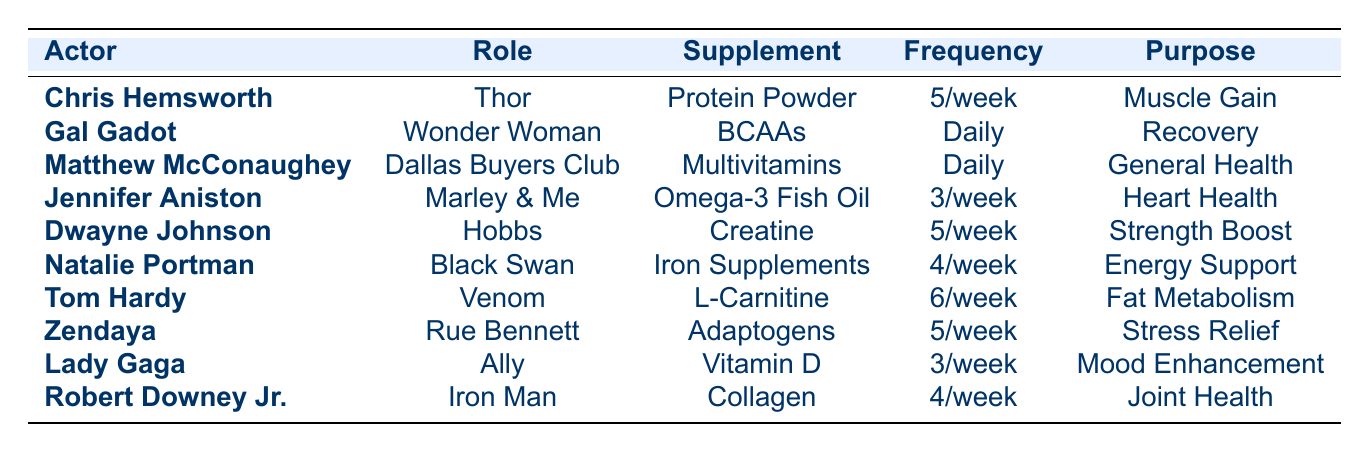What supplement does Chris Hemsworth use? The table lists Chris Hemsworth under the first row with the supplement type as Protein Powder.
Answer: Protein Powder Which actor uses BCAAs and how often? In the table, Gal Gadot is noted as using BCAAs with a usage frequency of 7 times per week.
Answer: Daily How many actors use a supplement frequency of 5 times per week? By reviewing the table, the actors who use a supplement frequency of 5 times per week are Chris Hemsworth, Dwayne Johnson, and Zendaya, totaling 3 actors.
Answer: 3 What is the purpose of the Iron Supplements taken by Natalie Portman? The table shows that Natalie Portman takes Iron Supplements for Energy Support.
Answer: Energy Support Which supplement has the least frequency of usage per week among the actors listed? Upon examining the usage frequencies in the table, both Omega-3 Fish Oil and Vitamin D are used 3 times a week, indicating they are the least used supplements among the actors.
Answer: Omega-3 Fish Oil and Vitamin D Is Matthew McConaughey using a supplement for muscle gain? The table indicates that Matthew McConaughey uses Multivitamins for General Health, not muscle gain.
Answer: No What is the average frequency of supplement usage among all actors? To find the average, add the frequencies (5+7+7+3+5+4+6+5+3+4 = 55) and divide by the number of actors (10), leading to an average frequency of 5.5.
Answer: 5.5 Which supplement is used for stress relief? Looking at the table, Zendaya's usage of Adaptogens is for Stress Relief.
Answer: Adaptogens How many actors are using supplements specifically for heart health? The table shows that only Jennifer Aniston uses a supplement (Omega-3 Fish Oil) specifically for heart health.
Answer: 1 Which actor has the highest supplement frequency and what is it? Examining the table, Tom Hardy has the highest frequency at 6 times per week with L-Carnitine for Fat Metabolism.
Answer: Tom Hardy, 6 times per week 